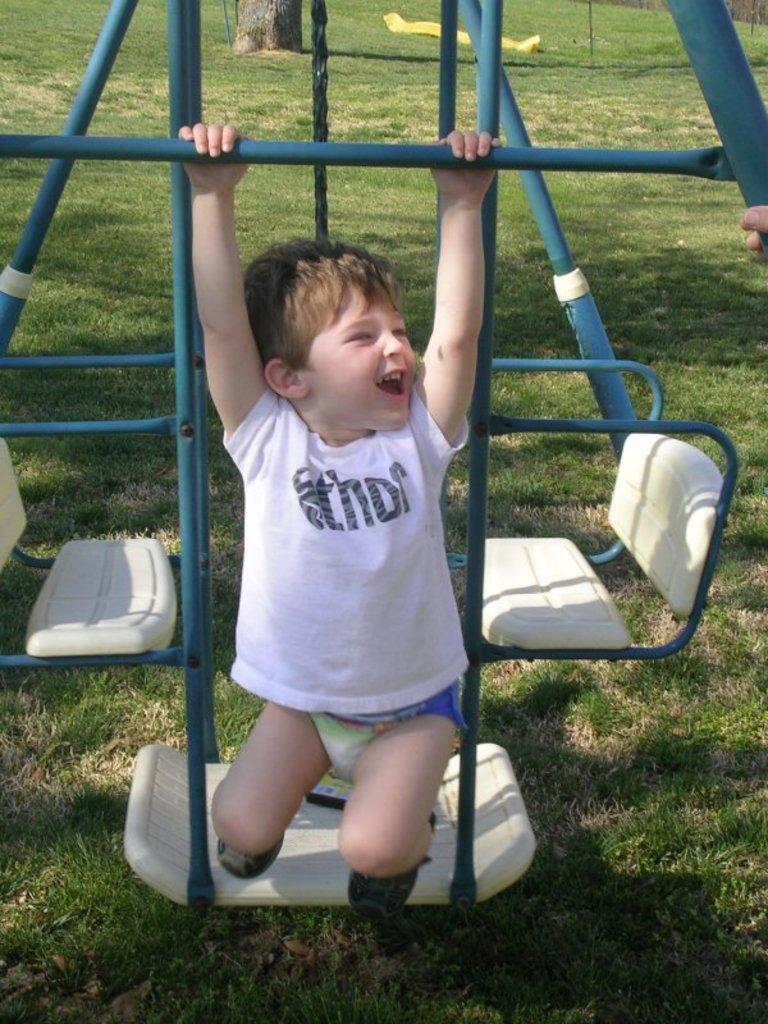Can you describe this image briefly? In this image there is a kid hanging from the metal rod. Behind him there are empty chairs. At the bottom of the image there is grass on the surface. In the background of the image there is a tree. There is a mesh and there is some object on the surface. 